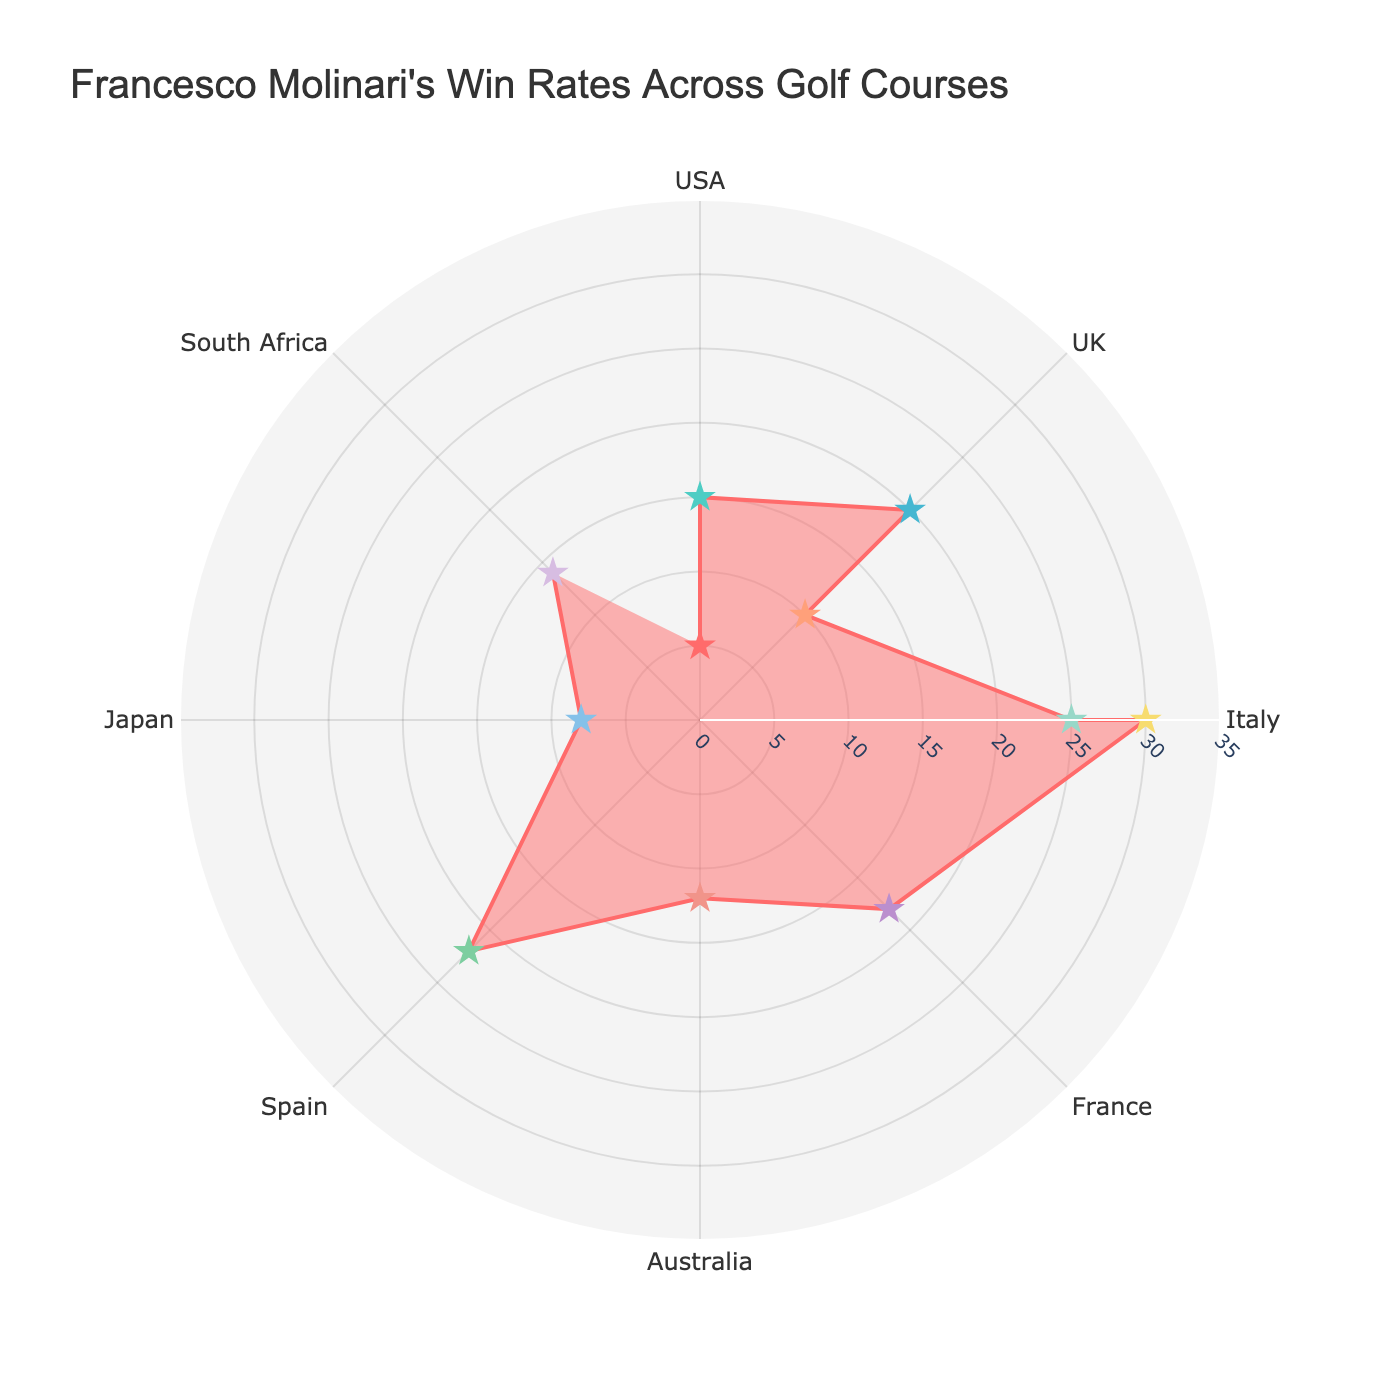What's the title of the figure? The title of the figure is prominently displayed at the top and usually summarizes the main information or insight provided by the figure.
Answer: Francesco Molinari's Win Rates Across Golf Courses How many golf courses are represented in the figure? Each data point in the figure represents a different golf course. Count the number of unique data points.
Answer: 11 Which location has the highest win rate for Molinari? Look for the data point with the highest radial distance and note its corresponding location.
Answer: Italy What's the win rate at Augusta National Golf Club? Identify the data point corresponding to Augusta National Golf Club and read its associated radial value.
Answer: 5% Between Real Club Valderrama in Spain and Gary Player Country Club in South Africa, which has a higher win rate for Molinari? Compare the radial distances of the two points and see which one is further from the center.
Answer: Real Club Valderrama What's the average win rate of Molinari in the USA? List the win rates of golf courses in the USA (5% for Augusta National Golf Club and 15% for Pebble Beach Golf Links), sum them up, and divide by the number of courses.
Answer: (5 + 15) / 2 = 10% Which course in Italy has a higher win rate, Parco di Monza Golf Club or Olgiata Golf Club? Compare the radial distances of these two data points and determine which one is further from the center.
Answer: Olgiata Golf Club Which location has the lowest win rate for Molinari? Find the data point with the smallest radial distance and note its corresponding location.
Answer: USA What's the median win rate of all the golf courses represented? List all win rates, order them, and find the middle value. If there is an even number of points, average the two middle values.
Answer: Median: 14% Between Royal Melbourne Golf Club in Australia and Naruo Golf Club in Japan, which has a lower win rate for Molinari? Compare the radial distances of these two data points and see which one is closer to the center.
Answer: Naruo Golf Club 